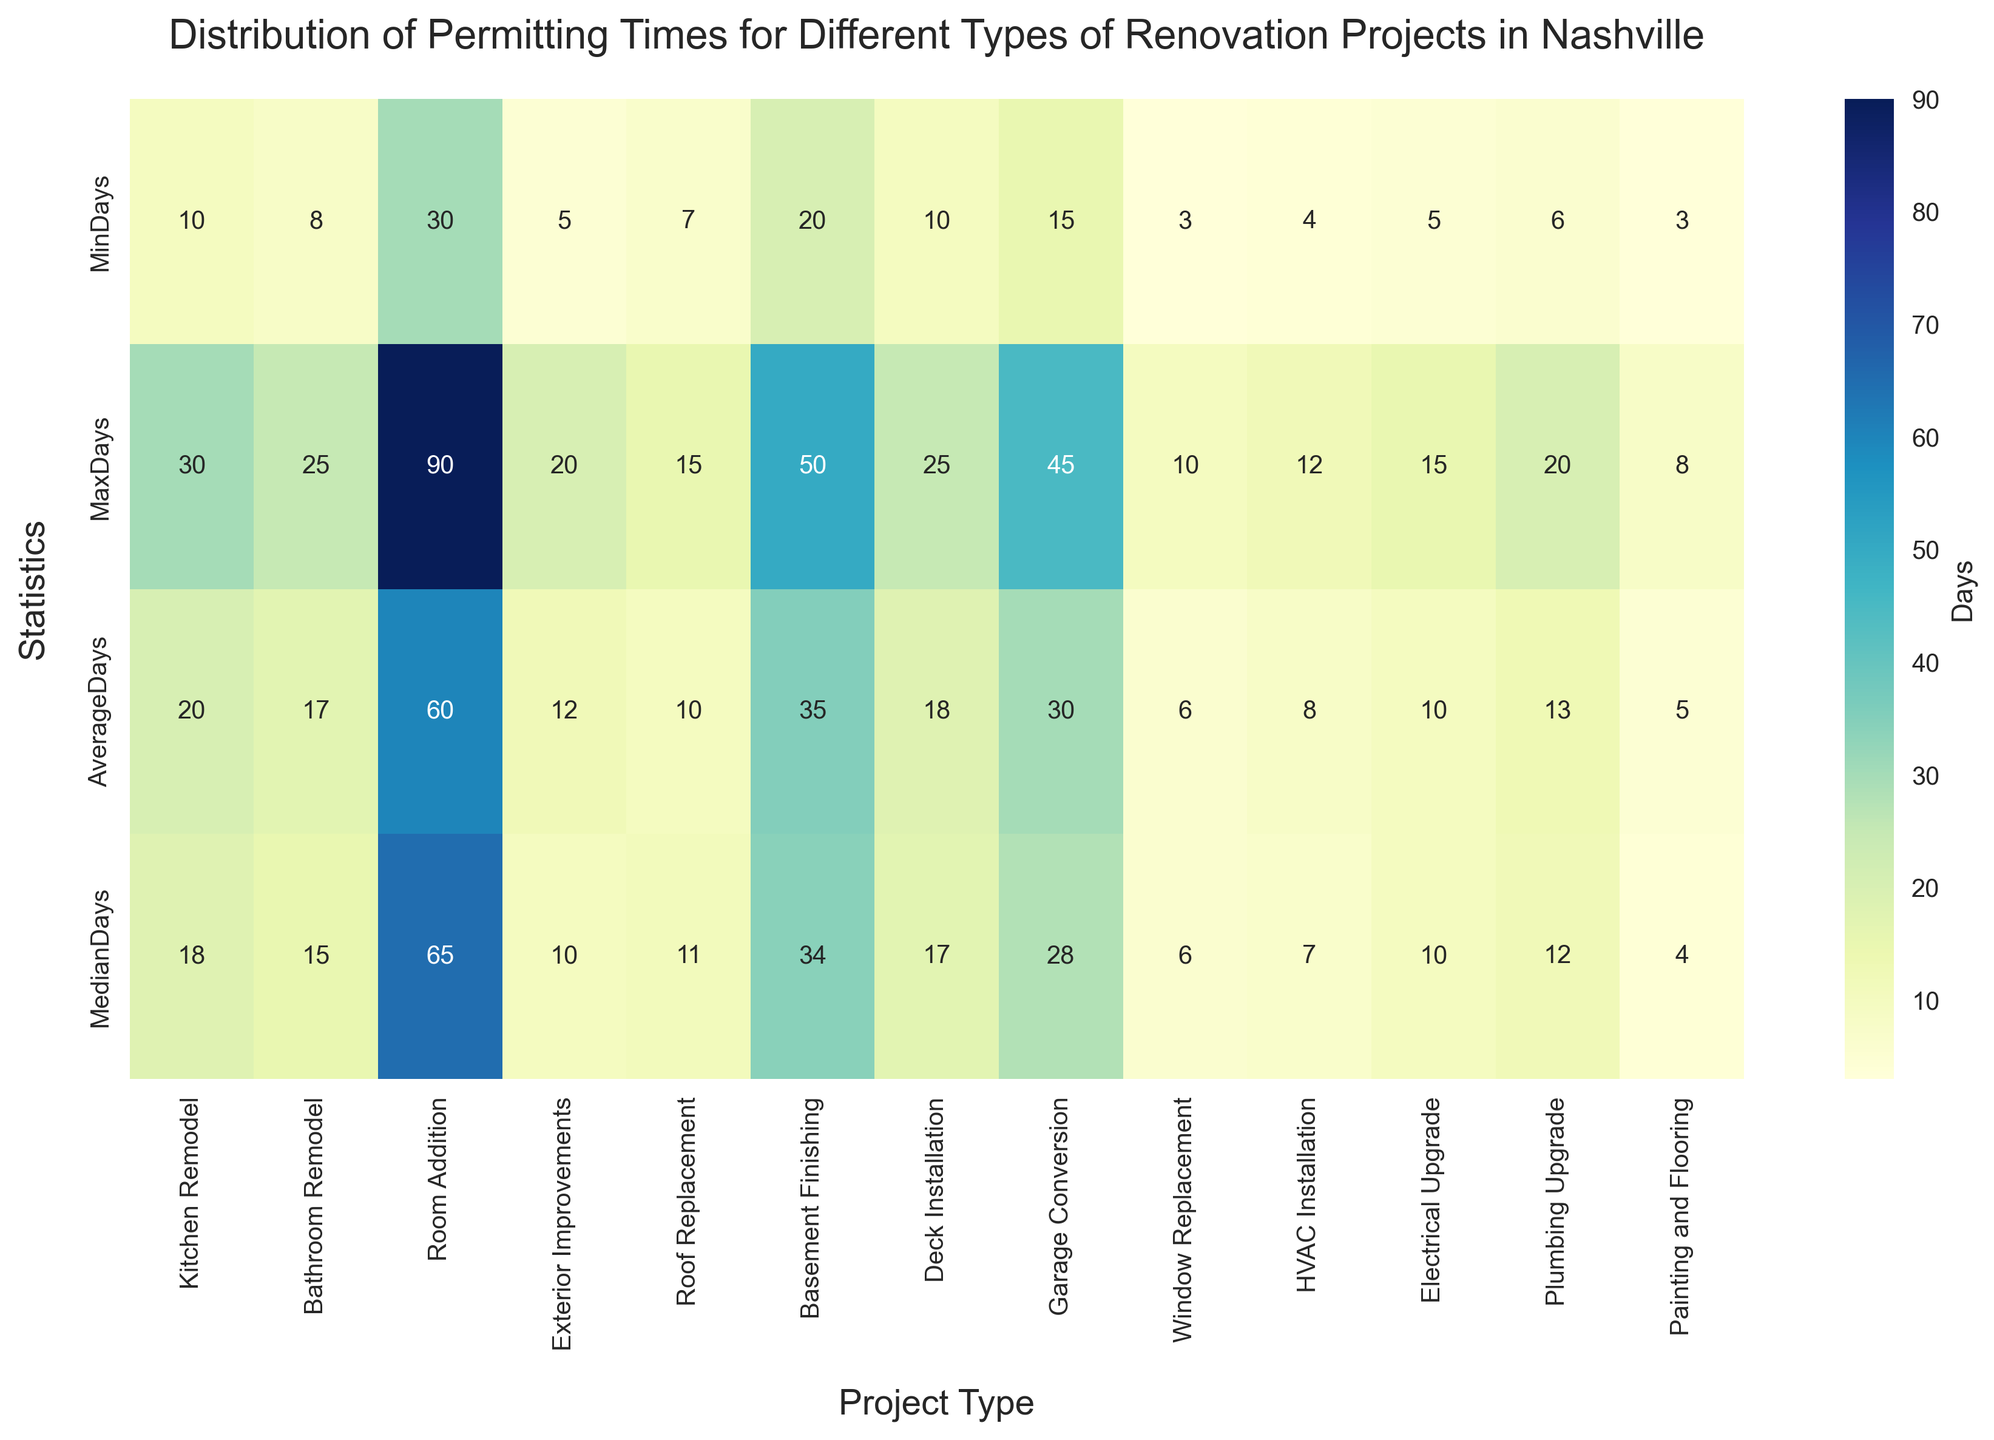What is the average permitting time for a Kitchen Remodel project? The heatmap shows the AverageDays statistic for Kitchen Remodel, which is 20 days.
Answer: 20 days Which project type has the shortest minimum permitting time? By observing the MinDays row in the heatmap, the smallest number is 3 days, which corresponds to Window Replacement and Painting and Flooring.
Answer: Window Replacement and Painting and Flooring How does the maximum permitting time for Room Addition compare to that of Basement Finishing? The heatmap shows that Room Addition has a MaxDays value of 90, while Basement Finishing has a MaxDays value of 50. Comparing these, 90 is greater than 50.
Answer: 90 days is greater than 50 days What’s the median permitting time for HVAC Installation? The heatmap indicates that, for HVAC Installation, the MedianDays statistic is 7 days.
Answer: 7 days Which project type has the highest average permitting time, and what is it? Referring to the AverageDays row in the heatmap, the highest number is 60 days for Room Addition.
Answer: Room Addition, 60 days What is the difference between the maximum permitting time for a Roof Replacement and a Plumbing Upgrade? The heatmap shows Roof Replacement has a MaxDays of 15 and Plumbing Upgrade has a MaxDays of 20. The difference is 20 - 15 = 5 days.
Answer: 5 days Among Kitchen Remodel, Bathroom Remodel, and Deck Installation, which project has the shortest average permitting time? Observing the AverageDays row, Kitchen Remodel has 20 days, Bathroom Remodel has 17 days, and Deck Installation has 18 days. The shortest average permitting time is for Bathroom Remodel.
Answer: Bathroom Remodel What is the total of the median permitting times for Electrical Upgrade, Plumbing Upgrade, and Painting and Flooring? Summing up the MedianDays values: Electrical Upgrade (10) + Plumbing Upgrade (12) + Painting and Flooring (4) = 10 + 12 + 4 = 26.
Answer: 26 days 